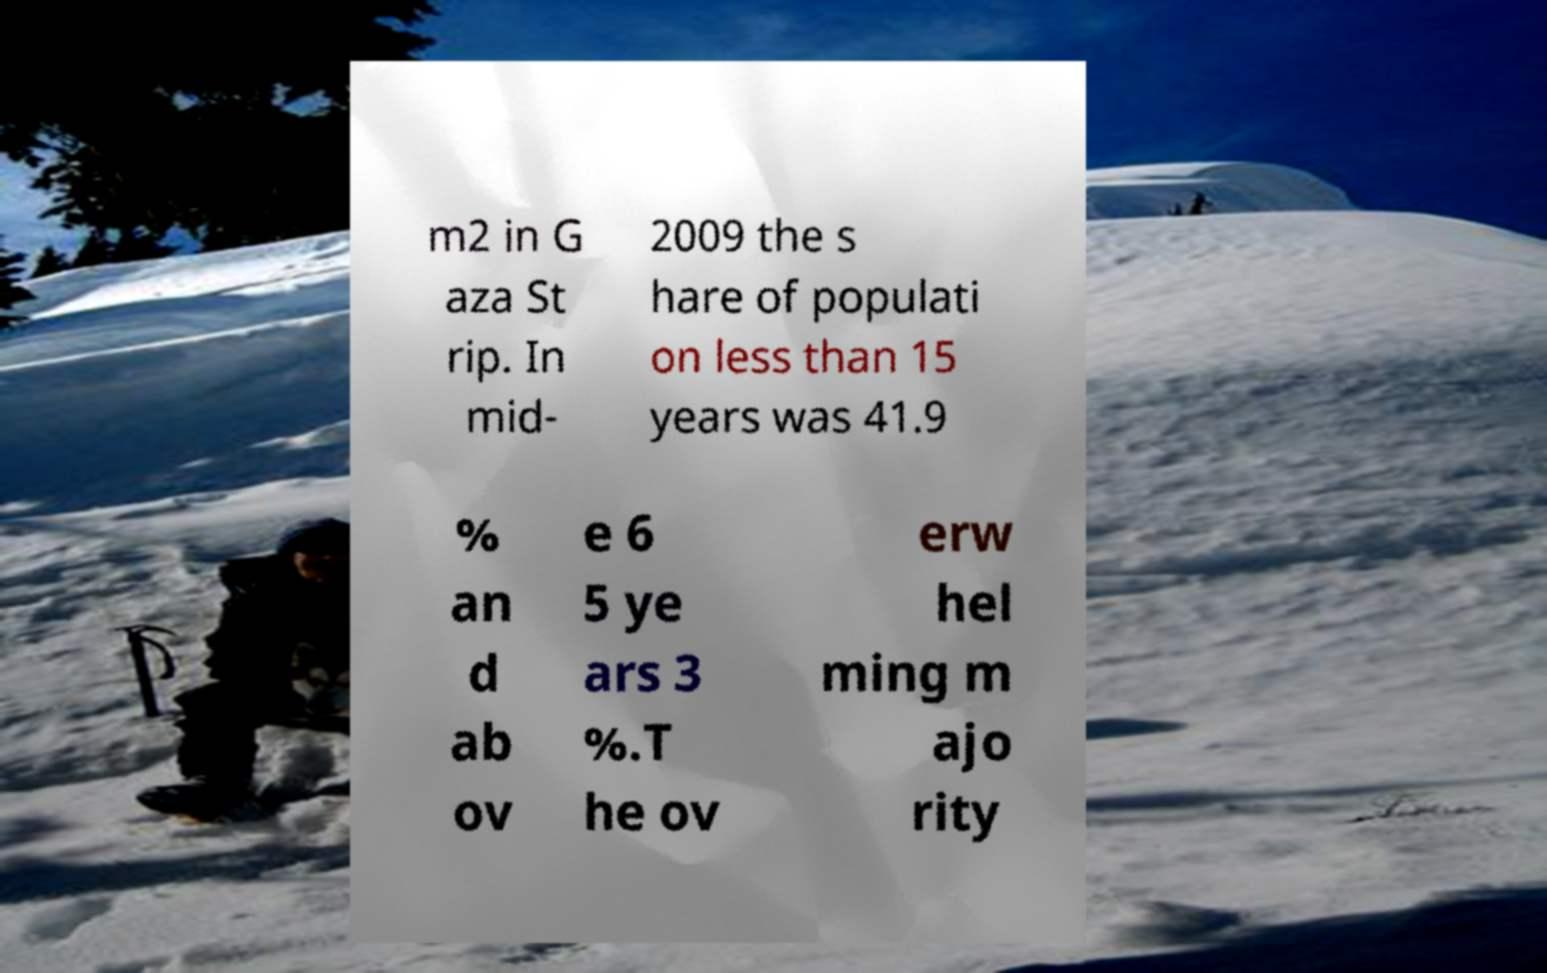What messages or text are displayed in this image? I need them in a readable, typed format. m2 in G aza St rip. In mid- 2009 the s hare of populati on less than 15 years was 41.9 % an d ab ov e 6 5 ye ars 3 %.T he ov erw hel ming m ajo rity 